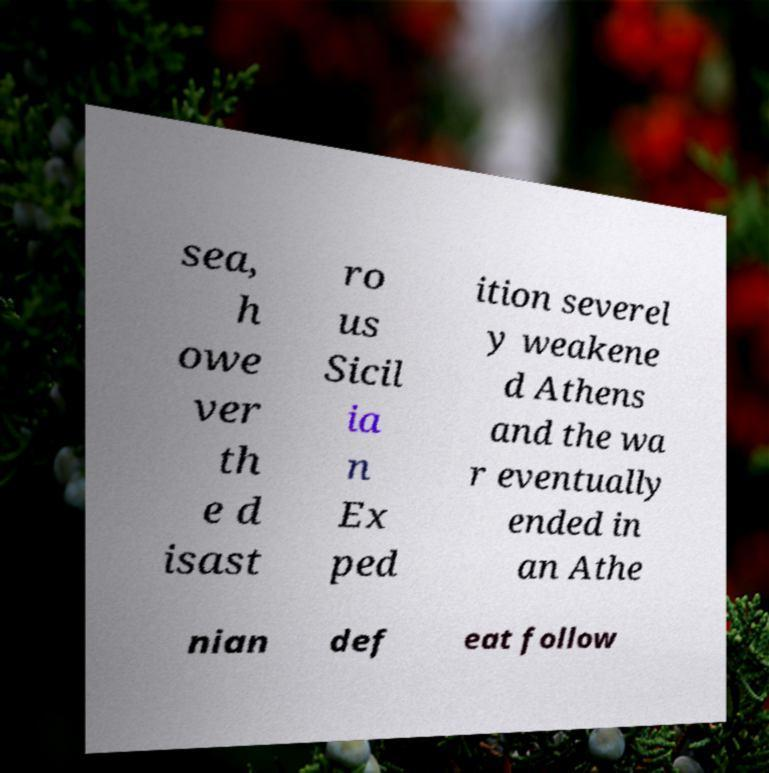Can you accurately transcribe the text from the provided image for me? sea, h owe ver th e d isast ro us Sicil ia n Ex ped ition severel y weakene d Athens and the wa r eventually ended in an Athe nian def eat follow 